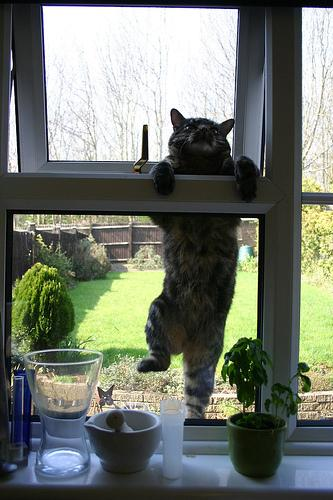Question: how many people are in the picture?
Choices:
A. One.
B. None.
C. Two.
D. Four.
Answer with the letter. Answer: B Question: what kind of animal is in the picture?
Choices:
A. Dog.
B. Fish.
C. Duck.
D. A cat.
Answer with the letter. Answer: D Question: what is behind the cat?
Choices:
A. A library.
B. A yard.
C. The TV.
D. Remote.
Answer with the letter. Answer: B Question: what is the cat trying to do?
Choices:
A. Climb through the window.
B. Jump off a table.
C. Claw out.
D. Crawling up the stock.
Answer with the letter. Answer: A Question: what is in the window seal?
Choices:
A. The kitten.
B. Stickers.
C. A plant.
D. Pie.
Answer with the letter. Answer: C Question: what was left opened?
Choices:
A. The freezer.
B. A window.
C. A drawer.
D. The cabinet.
Answer with the letter. Answer: B Question: what color is the fence behind the cat?
Choices:
A. White.
B. Brown.
C. Silver.
D. Black.
Answer with the letter. Answer: B 